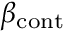Convert formula to latex. <formula><loc_0><loc_0><loc_500><loc_500>\beta _ { c o n t }</formula> 